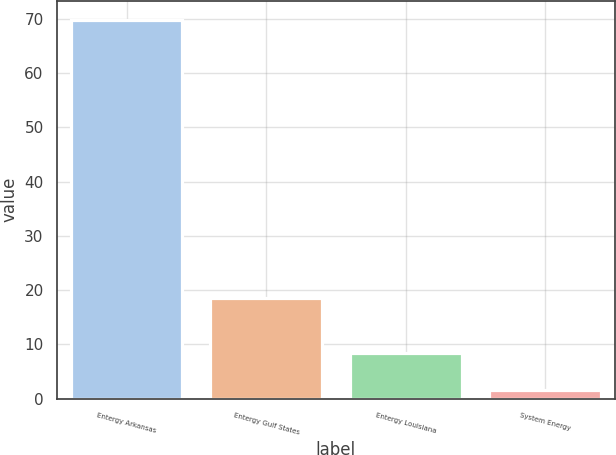Convert chart. <chart><loc_0><loc_0><loc_500><loc_500><bar_chart><fcel>Entergy Arkansas<fcel>Entergy Gulf States<fcel>Entergy Louisiana<fcel>System Energy<nl><fcel>69.8<fcel>18.5<fcel>8.42<fcel>1.6<nl></chart> 